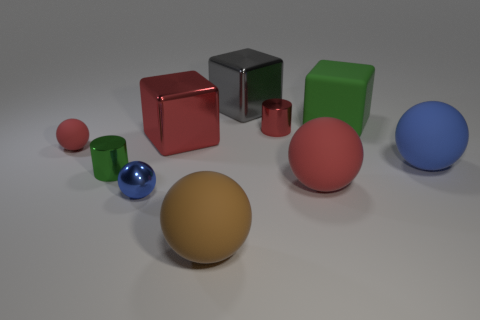There is a green thing left of the green thing that is right of the large brown ball; what is its material?
Provide a short and direct response. Metal. Are there more big objects behind the small red rubber object than big yellow things?
Offer a very short reply. Yes. How many other objects are there of the same color as the small matte object?
Offer a terse response. 3. What is the shape of the red rubber object that is the same size as the brown rubber ball?
Offer a terse response. Sphere. There is a green object that is right of the small metal cylinder left of the tiny blue object; how many large metal objects are behind it?
Give a very brief answer. 1. What number of metallic objects are either big brown cylinders or objects?
Give a very brief answer. 5. What color is the sphere that is on the left side of the brown thing and to the right of the small rubber object?
Provide a short and direct response. Blue. Do the red ball left of the blue shiny ball and the big brown rubber sphere have the same size?
Give a very brief answer. No. How many things are either things that are to the right of the big green rubber thing or big green cylinders?
Your answer should be compact. 1. Is there a green cylinder that has the same size as the matte block?
Your answer should be compact. No. 